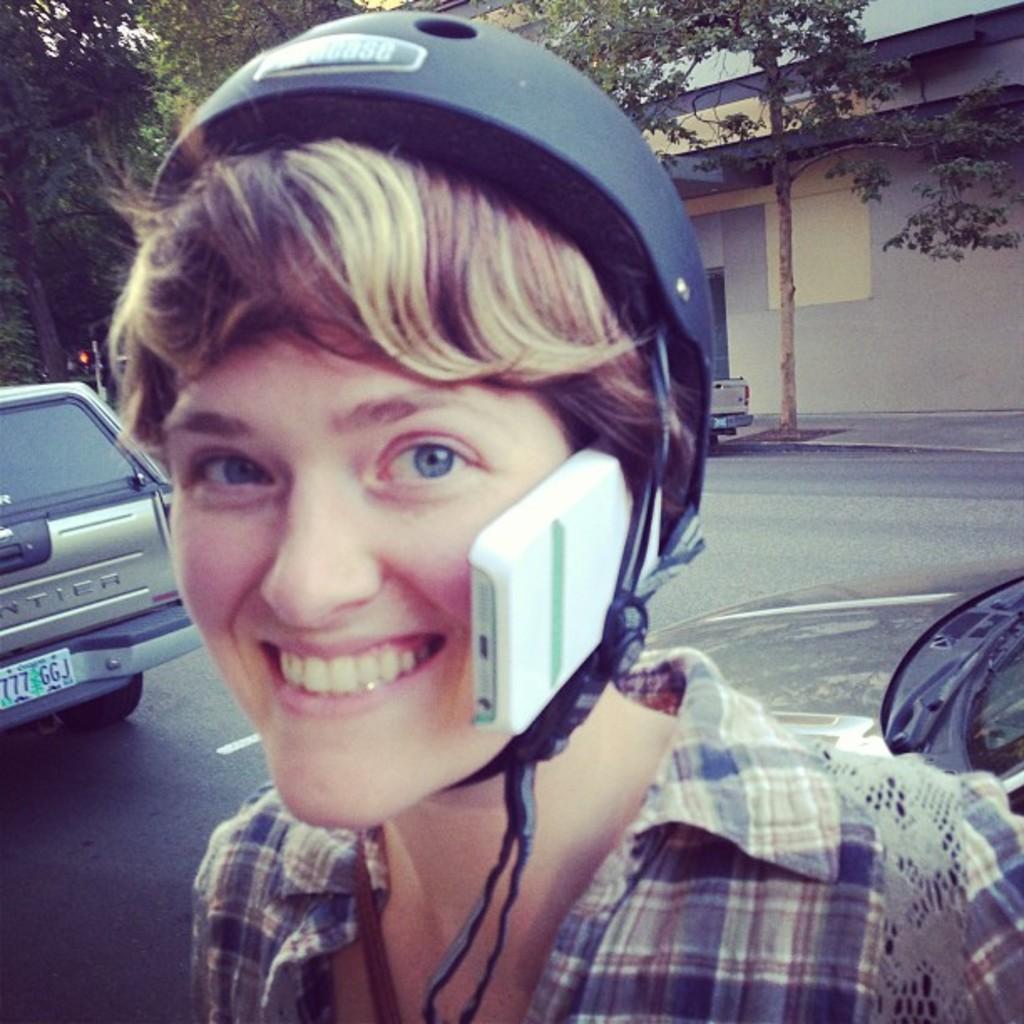Describe this image in one or two sentences. There is a person wearing helmet and holding a mobile in the helmet. On the left side there is a vehicle. In the back there is a road, trees and a building. 